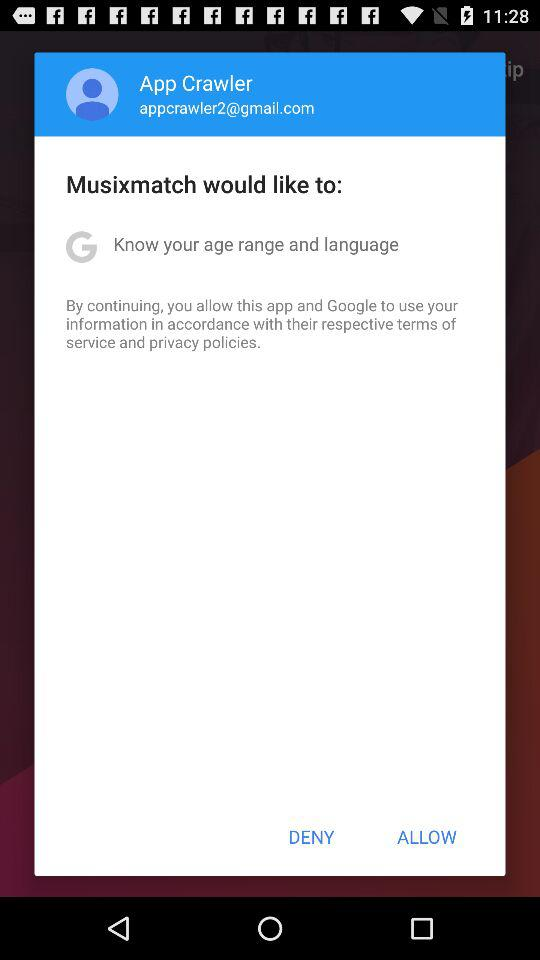What is the email address given? The email address is appcrawler2@gmail.com. 